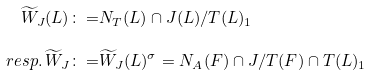Convert formula to latex. <formula><loc_0><loc_0><loc_500><loc_500>\widetilde { W } _ { J } ( L ) \colon = & N _ { T } ( L ) \cap J ( L ) / T ( L ) _ { 1 } \\ r e s p . \, \widetilde { W } _ { J } \colon = & \widetilde { W } _ { J } ( L ) ^ { \sigma } = N _ { A } ( F ) \cap J / T ( F ) \cap T ( L ) _ { 1 }</formula> 